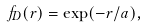<formula> <loc_0><loc_0><loc_500><loc_500>f _ { D } ( r ) = \exp ( - r / a ) ,</formula> 